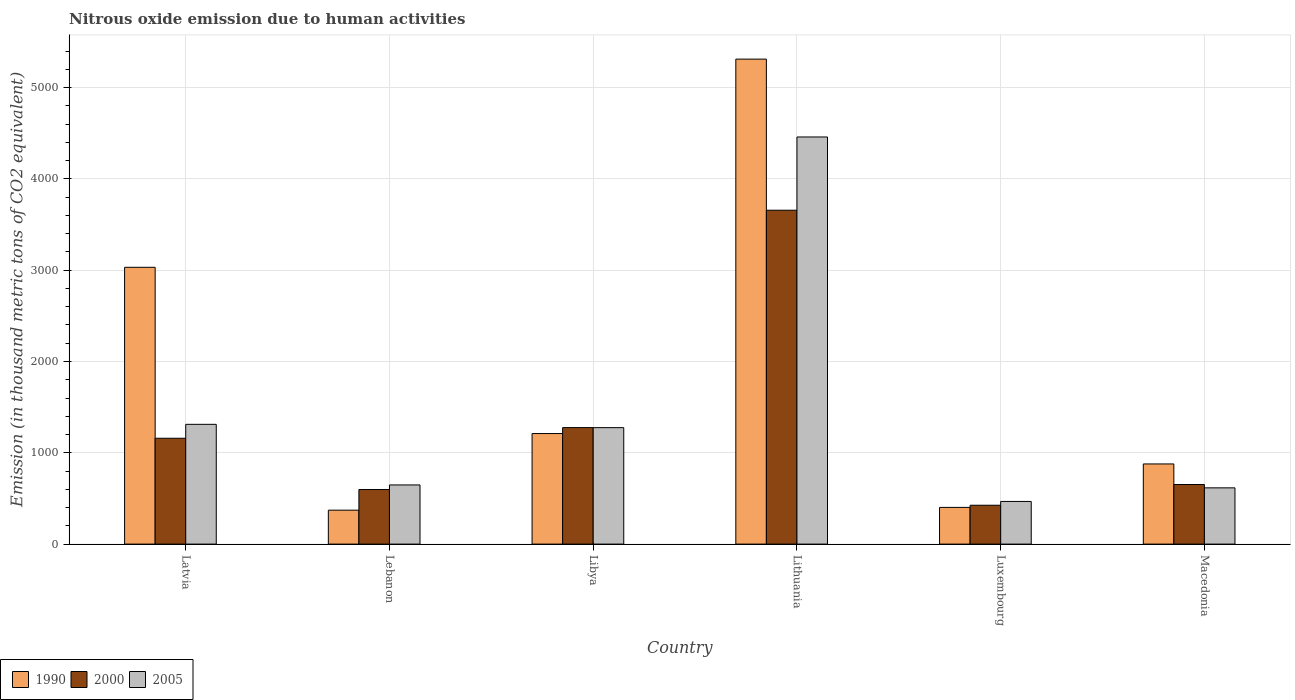How many bars are there on the 3rd tick from the left?
Your answer should be very brief. 3. How many bars are there on the 4th tick from the right?
Provide a short and direct response. 3. What is the label of the 1st group of bars from the left?
Your answer should be very brief. Latvia. What is the amount of nitrous oxide emitted in 2005 in Macedonia?
Your answer should be compact. 616.1. Across all countries, what is the maximum amount of nitrous oxide emitted in 2005?
Your response must be concise. 4459.4. Across all countries, what is the minimum amount of nitrous oxide emitted in 2005?
Make the answer very short. 467.2. In which country was the amount of nitrous oxide emitted in 2000 maximum?
Make the answer very short. Lithuania. In which country was the amount of nitrous oxide emitted in 2005 minimum?
Provide a short and direct response. Luxembourg. What is the total amount of nitrous oxide emitted in 2000 in the graph?
Offer a terse response. 7768.7. What is the difference between the amount of nitrous oxide emitted in 2005 in Lithuania and that in Macedonia?
Keep it short and to the point. 3843.3. What is the difference between the amount of nitrous oxide emitted in 2005 in Libya and the amount of nitrous oxide emitted in 2000 in Latvia?
Offer a terse response. 116.1. What is the average amount of nitrous oxide emitted in 1990 per country?
Offer a very short reply. 1867.7. What is the difference between the amount of nitrous oxide emitted of/in 2005 and amount of nitrous oxide emitted of/in 1990 in Lithuania?
Make the answer very short. -852.7. What is the ratio of the amount of nitrous oxide emitted in 1990 in Lithuania to that in Macedonia?
Your response must be concise. 6.05. Is the amount of nitrous oxide emitted in 1990 in Lithuania less than that in Luxembourg?
Provide a succinct answer. No. What is the difference between the highest and the second highest amount of nitrous oxide emitted in 1990?
Provide a succinct answer. 4101.3. What is the difference between the highest and the lowest amount of nitrous oxide emitted in 2000?
Provide a short and direct response. 3231.4. What does the 2nd bar from the right in Latvia represents?
Ensure brevity in your answer.  2000. How many bars are there?
Your answer should be compact. 18. What is the difference between two consecutive major ticks on the Y-axis?
Make the answer very short. 1000. Are the values on the major ticks of Y-axis written in scientific E-notation?
Your answer should be compact. No. Does the graph contain any zero values?
Provide a succinct answer. No. Does the graph contain grids?
Offer a terse response. Yes. Where does the legend appear in the graph?
Offer a very short reply. Bottom left. How many legend labels are there?
Make the answer very short. 3. How are the legend labels stacked?
Make the answer very short. Horizontal. What is the title of the graph?
Provide a short and direct response. Nitrous oxide emission due to human activities. What is the label or title of the X-axis?
Your answer should be compact. Country. What is the label or title of the Y-axis?
Your response must be concise. Emission (in thousand metric tons of CO2 equivalent). What is the Emission (in thousand metric tons of CO2 equivalent) of 1990 in Latvia?
Provide a succinct answer. 3031.8. What is the Emission (in thousand metric tons of CO2 equivalent) in 2000 in Latvia?
Offer a terse response. 1159.4. What is the Emission (in thousand metric tons of CO2 equivalent) in 2005 in Latvia?
Provide a short and direct response. 1311.8. What is the Emission (in thousand metric tons of CO2 equivalent) in 1990 in Lebanon?
Your answer should be compact. 371.6. What is the Emission (in thousand metric tons of CO2 equivalent) in 2000 in Lebanon?
Give a very brief answer. 597.8. What is the Emission (in thousand metric tons of CO2 equivalent) of 2005 in Lebanon?
Offer a terse response. 648. What is the Emission (in thousand metric tons of CO2 equivalent) of 1990 in Libya?
Offer a terse response. 1210.8. What is the Emission (in thousand metric tons of CO2 equivalent) of 2000 in Libya?
Ensure brevity in your answer.  1276.1. What is the Emission (in thousand metric tons of CO2 equivalent) in 2005 in Libya?
Offer a terse response. 1275.5. What is the Emission (in thousand metric tons of CO2 equivalent) in 1990 in Lithuania?
Your answer should be very brief. 5312.1. What is the Emission (in thousand metric tons of CO2 equivalent) of 2000 in Lithuania?
Your response must be concise. 3657. What is the Emission (in thousand metric tons of CO2 equivalent) of 2005 in Lithuania?
Make the answer very short. 4459.4. What is the Emission (in thousand metric tons of CO2 equivalent) of 1990 in Luxembourg?
Ensure brevity in your answer.  402. What is the Emission (in thousand metric tons of CO2 equivalent) in 2000 in Luxembourg?
Offer a terse response. 425.6. What is the Emission (in thousand metric tons of CO2 equivalent) in 2005 in Luxembourg?
Keep it short and to the point. 467.2. What is the Emission (in thousand metric tons of CO2 equivalent) in 1990 in Macedonia?
Offer a terse response. 877.9. What is the Emission (in thousand metric tons of CO2 equivalent) in 2000 in Macedonia?
Your response must be concise. 652.8. What is the Emission (in thousand metric tons of CO2 equivalent) of 2005 in Macedonia?
Keep it short and to the point. 616.1. Across all countries, what is the maximum Emission (in thousand metric tons of CO2 equivalent) of 1990?
Your response must be concise. 5312.1. Across all countries, what is the maximum Emission (in thousand metric tons of CO2 equivalent) in 2000?
Offer a terse response. 3657. Across all countries, what is the maximum Emission (in thousand metric tons of CO2 equivalent) in 2005?
Your answer should be compact. 4459.4. Across all countries, what is the minimum Emission (in thousand metric tons of CO2 equivalent) in 1990?
Make the answer very short. 371.6. Across all countries, what is the minimum Emission (in thousand metric tons of CO2 equivalent) of 2000?
Provide a short and direct response. 425.6. Across all countries, what is the minimum Emission (in thousand metric tons of CO2 equivalent) in 2005?
Provide a succinct answer. 467.2. What is the total Emission (in thousand metric tons of CO2 equivalent) of 1990 in the graph?
Ensure brevity in your answer.  1.12e+04. What is the total Emission (in thousand metric tons of CO2 equivalent) in 2000 in the graph?
Provide a succinct answer. 7768.7. What is the total Emission (in thousand metric tons of CO2 equivalent) of 2005 in the graph?
Provide a succinct answer. 8778. What is the difference between the Emission (in thousand metric tons of CO2 equivalent) in 1990 in Latvia and that in Lebanon?
Provide a succinct answer. 2660.2. What is the difference between the Emission (in thousand metric tons of CO2 equivalent) in 2000 in Latvia and that in Lebanon?
Offer a very short reply. 561.6. What is the difference between the Emission (in thousand metric tons of CO2 equivalent) of 2005 in Latvia and that in Lebanon?
Make the answer very short. 663.8. What is the difference between the Emission (in thousand metric tons of CO2 equivalent) of 1990 in Latvia and that in Libya?
Give a very brief answer. 1821. What is the difference between the Emission (in thousand metric tons of CO2 equivalent) in 2000 in Latvia and that in Libya?
Give a very brief answer. -116.7. What is the difference between the Emission (in thousand metric tons of CO2 equivalent) in 2005 in Latvia and that in Libya?
Offer a very short reply. 36.3. What is the difference between the Emission (in thousand metric tons of CO2 equivalent) of 1990 in Latvia and that in Lithuania?
Keep it short and to the point. -2280.3. What is the difference between the Emission (in thousand metric tons of CO2 equivalent) of 2000 in Latvia and that in Lithuania?
Offer a terse response. -2497.6. What is the difference between the Emission (in thousand metric tons of CO2 equivalent) of 2005 in Latvia and that in Lithuania?
Ensure brevity in your answer.  -3147.6. What is the difference between the Emission (in thousand metric tons of CO2 equivalent) of 1990 in Latvia and that in Luxembourg?
Your response must be concise. 2629.8. What is the difference between the Emission (in thousand metric tons of CO2 equivalent) in 2000 in Latvia and that in Luxembourg?
Your response must be concise. 733.8. What is the difference between the Emission (in thousand metric tons of CO2 equivalent) in 2005 in Latvia and that in Luxembourg?
Your response must be concise. 844.6. What is the difference between the Emission (in thousand metric tons of CO2 equivalent) of 1990 in Latvia and that in Macedonia?
Your answer should be very brief. 2153.9. What is the difference between the Emission (in thousand metric tons of CO2 equivalent) of 2000 in Latvia and that in Macedonia?
Offer a very short reply. 506.6. What is the difference between the Emission (in thousand metric tons of CO2 equivalent) of 2005 in Latvia and that in Macedonia?
Provide a short and direct response. 695.7. What is the difference between the Emission (in thousand metric tons of CO2 equivalent) of 1990 in Lebanon and that in Libya?
Provide a succinct answer. -839.2. What is the difference between the Emission (in thousand metric tons of CO2 equivalent) of 2000 in Lebanon and that in Libya?
Offer a terse response. -678.3. What is the difference between the Emission (in thousand metric tons of CO2 equivalent) of 2005 in Lebanon and that in Libya?
Provide a succinct answer. -627.5. What is the difference between the Emission (in thousand metric tons of CO2 equivalent) of 1990 in Lebanon and that in Lithuania?
Provide a succinct answer. -4940.5. What is the difference between the Emission (in thousand metric tons of CO2 equivalent) in 2000 in Lebanon and that in Lithuania?
Provide a short and direct response. -3059.2. What is the difference between the Emission (in thousand metric tons of CO2 equivalent) in 2005 in Lebanon and that in Lithuania?
Your response must be concise. -3811.4. What is the difference between the Emission (in thousand metric tons of CO2 equivalent) of 1990 in Lebanon and that in Luxembourg?
Give a very brief answer. -30.4. What is the difference between the Emission (in thousand metric tons of CO2 equivalent) in 2000 in Lebanon and that in Luxembourg?
Your response must be concise. 172.2. What is the difference between the Emission (in thousand metric tons of CO2 equivalent) of 2005 in Lebanon and that in Luxembourg?
Ensure brevity in your answer.  180.8. What is the difference between the Emission (in thousand metric tons of CO2 equivalent) in 1990 in Lebanon and that in Macedonia?
Your response must be concise. -506.3. What is the difference between the Emission (in thousand metric tons of CO2 equivalent) of 2000 in Lebanon and that in Macedonia?
Provide a short and direct response. -55. What is the difference between the Emission (in thousand metric tons of CO2 equivalent) of 2005 in Lebanon and that in Macedonia?
Your answer should be very brief. 31.9. What is the difference between the Emission (in thousand metric tons of CO2 equivalent) in 1990 in Libya and that in Lithuania?
Ensure brevity in your answer.  -4101.3. What is the difference between the Emission (in thousand metric tons of CO2 equivalent) of 2000 in Libya and that in Lithuania?
Your answer should be compact. -2380.9. What is the difference between the Emission (in thousand metric tons of CO2 equivalent) in 2005 in Libya and that in Lithuania?
Your answer should be compact. -3183.9. What is the difference between the Emission (in thousand metric tons of CO2 equivalent) of 1990 in Libya and that in Luxembourg?
Offer a very short reply. 808.8. What is the difference between the Emission (in thousand metric tons of CO2 equivalent) in 2000 in Libya and that in Luxembourg?
Your answer should be very brief. 850.5. What is the difference between the Emission (in thousand metric tons of CO2 equivalent) of 2005 in Libya and that in Luxembourg?
Offer a terse response. 808.3. What is the difference between the Emission (in thousand metric tons of CO2 equivalent) of 1990 in Libya and that in Macedonia?
Your response must be concise. 332.9. What is the difference between the Emission (in thousand metric tons of CO2 equivalent) of 2000 in Libya and that in Macedonia?
Give a very brief answer. 623.3. What is the difference between the Emission (in thousand metric tons of CO2 equivalent) in 2005 in Libya and that in Macedonia?
Your response must be concise. 659.4. What is the difference between the Emission (in thousand metric tons of CO2 equivalent) of 1990 in Lithuania and that in Luxembourg?
Your answer should be very brief. 4910.1. What is the difference between the Emission (in thousand metric tons of CO2 equivalent) of 2000 in Lithuania and that in Luxembourg?
Offer a very short reply. 3231.4. What is the difference between the Emission (in thousand metric tons of CO2 equivalent) in 2005 in Lithuania and that in Luxembourg?
Provide a short and direct response. 3992.2. What is the difference between the Emission (in thousand metric tons of CO2 equivalent) in 1990 in Lithuania and that in Macedonia?
Provide a short and direct response. 4434.2. What is the difference between the Emission (in thousand metric tons of CO2 equivalent) of 2000 in Lithuania and that in Macedonia?
Make the answer very short. 3004.2. What is the difference between the Emission (in thousand metric tons of CO2 equivalent) in 2005 in Lithuania and that in Macedonia?
Offer a very short reply. 3843.3. What is the difference between the Emission (in thousand metric tons of CO2 equivalent) in 1990 in Luxembourg and that in Macedonia?
Provide a short and direct response. -475.9. What is the difference between the Emission (in thousand metric tons of CO2 equivalent) in 2000 in Luxembourg and that in Macedonia?
Make the answer very short. -227.2. What is the difference between the Emission (in thousand metric tons of CO2 equivalent) of 2005 in Luxembourg and that in Macedonia?
Give a very brief answer. -148.9. What is the difference between the Emission (in thousand metric tons of CO2 equivalent) of 1990 in Latvia and the Emission (in thousand metric tons of CO2 equivalent) of 2000 in Lebanon?
Give a very brief answer. 2434. What is the difference between the Emission (in thousand metric tons of CO2 equivalent) in 1990 in Latvia and the Emission (in thousand metric tons of CO2 equivalent) in 2005 in Lebanon?
Offer a very short reply. 2383.8. What is the difference between the Emission (in thousand metric tons of CO2 equivalent) of 2000 in Latvia and the Emission (in thousand metric tons of CO2 equivalent) of 2005 in Lebanon?
Ensure brevity in your answer.  511.4. What is the difference between the Emission (in thousand metric tons of CO2 equivalent) of 1990 in Latvia and the Emission (in thousand metric tons of CO2 equivalent) of 2000 in Libya?
Offer a very short reply. 1755.7. What is the difference between the Emission (in thousand metric tons of CO2 equivalent) in 1990 in Latvia and the Emission (in thousand metric tons of CO2 equivalent) in 2005 in Libya?
Your response must be concise. 1756.3. What is the difference between the Emission (in thousand metric tons of CO2 equivalent) in 2000 in Latvia and the Emission (in thousand metric tons of CO2 equivalent) in 2005 in Libya?
Your answer should be very brief. -116.1. What is the difference between the Emission (in thousand metric tons of CO2 equivalent) in 1990 in Latvia and the Emission (in thousand metric tons of CO2 equivalent) in 2000 in Lithuania?
Provide a short and direct response. -625.2. What is the difference between the Emission (in thousand metric tons of CO2 equivalent) in 1990 in Latvia and the Emission (in thousand metric tons of CO2 equivalent) in 2005 in Lithuania?
Your answer should be compact. -1427.6. What is the difference between the Emission (in thousand metric tons of CO2 equivalent) in 2000 in Latvia and the Emission (in thousand metric tons of CO2 equivalent) in 2005 in Lithuania?
Give a very brief answer. -3300. What is the difference between the Emission (in thousand metric tons of CO2 equivalent) of 1990 in Latvia and the Emission (in thousand metric tons of CO2 equivalent) of 2000 in Luxembourg?
Your response must be concise. 2606.2. What is the difference between the Emission (in thousand metric tons of CO2 equivalent) of 1990 in Latvia and the Emission (in thousand metric tons of CO2 equivalent) of 2005 in Luxembourg?
Give a very brief answer. 2564.6. What is the difference between the Emission (in thousand metric tons of CO2 equivalent) of 2000 in Latvia and the Emission (in thousand metric tons of CO2 equivalent) of 2005 in Luxembourg?
Offer a terse response. 692.2. What is the difference between the Emission (in thousand metric tons of CO2 equivalent) in 1990 in Latvia and the Emission (in thousand metric tons of CO2 equivalent) in 2000 in Macedonia?
Your answer should be compact. 2379. What is the difference between the Emission (in thousand metric tons of CO2 equivalent) in 1990 in Latvia and the Emission (in thousand metric tons of CO2 equivalent) in 2005 in Macedonia?
Ensure brevity in your answer.  2415.7. What is the difference between the Emission (in thousand metric tons of CO2 equivalent) in 2000 in Latvia and the Emission (in thousand metric tons of CO2 equivalent) in 2005 in Macedonia?
Make the answer very short. 543.3. What is the difference between the Emission (in thousand metric tons of CO2 equivalent) in 1990 in Lebanon and the Emission (in thousand metric tons of CO2 equivalent) in 2000 in Libya?
Your response must be concise. -904.5. What is the difference between the Emission (in thousand metric tons of CO2 equivalent) in 1990 in Lebanon and the Emission (in thousand metric tons of CO2 equivalent) in 2005 in Libya?
Keep it short and to the point. -903.9. What is the difference between the Emission (in thousand metric tons of CO2 equivalent) in 2000 in Lebanon and the Emission (in thousand metric tons of CO2 equivalent) in 2005 in Libya?
Offer a terse response. -677.7. What is the difference between the Emission (in thousand metric tons of CO2 equivalent) of 1990 in Lebanon and the Emission (in thousand metric tons of CO2 equivalent) of 2000 in Lithuania?
Ensure brevity in your answer.  -3285.4. What is the difference between the Emission (in thousand metric tons of CO2 equivalent) in 1990 in Lebanon and the Emission (in thousand metric tons of CO2 equivalent) in 2005 in Lithuania?
Ensure brevity in your answer.  -4087.8. What is the difference between the Emission (in thousand metric tons of CO2 equivalent) in 2000 in Lebanon and the Emission (in thousand metric tons of CO2 equivalent) in 2005 in Lithuania?
Offer a terse response. -3861.6. What is the difference between the Emission (in thousand metric tons of CO2 equivalent) in 1990 in Lebanon and the Emission (in thousand metric tons of CO2 equivalent) in 2000 in Luxembourg?
Provide a succinct answer. -54. What is the difference between the Emission (in thousand metric tons of CO2 equivalent) of 1990 in Lebanon and the Emission (in thousand metric tons of CO2 equivalent) of 2005 in Luxembourg?
Your answer should be very brief. -95.6. What is the difference between the Emission (in thousand metric tons of CO2 equivalent) of 2000 in Lebanon and the Emission (in thousand metric tons of CO2 equivalent) of 2005 in Luxembourg?
Make the answer very short. 130.6. What is the difference between the Emission (in thousand metric tons of CO2 equivalent) of 1990 in Lebanon and the Emission (in thousand metric tons of CO2 equivalent) of 2000 in Macedonia?
Make the answer very short. -281.2. What is the difference between the Emission (in thousand metric tons of CO2 equivalent) of 1990 in Lebanon and the Emission (in thousand metric tons of CO2 equivalent) of 2005 in Macedonia?
Your answer should be very brief. -244.5. What is the difference between the Emission (in thousand metric tons of CO2 equivalent) in 2000 in Lebanon and the Emission (in thousand metric tons of CO2 equivalent) in 2005 in Macedonia?
Offer a very short reply. -18.3. What is the difference between the Emission (in thousand metric tons of CO2 equivalent) in 1990 in Libya and the Emission (in thousand metric tons of CO2 equivalent) in 2000 in Lithuania?
Offer a very short reply. -2446.2. What is the difference between the Emission (in thousand metric tons of CO2 equivalent) in 1990 in Libya and the Emission (in thousand metric tons of CO2 equivalent) in 2005 in Lithuania?
Make the answer very short. -3248.6. What is the difference between the Emission (in thousand metric tons of CO2 equivalent) in 2000 in Libya and the Emission (in thousand metric tons of CO2 equivalent) in 2005 in Lithuania?
Your answer should be compact. -3183.3. What is the difference between the Emission (in thousand metric tons of CO2 equivalent) in 1990 in Libya and the Emission (in thousand metric tons of CO2 equivalent) in 2000 in Luxembourg?
Your answer should be very brief. 785.2. What is the difference between the Emission (in thousand metric tons of CO2 equivalent) of 1990 in Libya and the Emission (in thousand metric tons of CO2 equivalent) of 2005 in Luxembourg?
Offer a terse response. 743.6. What is the difference between the Emission (in thousand metric tons of CO2 equivalent) of 2000 in Libya and the Emission (in thousand metric tons of CO2 equivalent) of 2005 in Luxembourg?
Offer a very short reply. 808.9. What is the difference between the Emission (in thousand metric tons of CO2 equivalent) of 1990 in Libya and the Emission (in thousand metric tons of CO2 equivalent) of 2000 in Macedonia?
Your response must be concise. 558. What is the difference between the Emission (in thousand metric tons of CO2 equivalent) of 1990 in Libya and the Emission (in thousand metric tons of CO2 equivalent) of 2005 in Macedonia?
Give a very brief answer. 594.7. What is the difference between the Emission (in thousand metric tons of CO2 equivalent) of 2000 in Libya and the Emission (in thousand metric tons of CO2 equivalent) of 2005 in Macedonia?
Your response must be concise. 660. What is the difference between the Emission (in thousand metric tons of CO2 equivalent) in 1990 in Lithuania and the Emission (in thousand metric tons of CO2 equivalent) in 2000 in Luxembourg?
Keep it short and to the point. 4886.5. What is the difference between the Emission (in thousand metric tons of CO2 equivalent) in 1990 in Lithuania and the Emission (in thousand metric tons of CO2 equivalent) in 2005 in Luxembourg?
Your answer should be compact. 4844.9. What is the difference between the Emission (in thousand metric tons of CO2 equivalent) in 2000 in Lithuania and the Emission (in thousand metric tons of CO2 equivalent) in 2005 in Luxembourg?
Ensure brevity in your answer.  3189.8. What is the difference between the Emission (in thousand metric tons of CO2 equivalent) of 1990 in Lithuania and the Emission (in thousand metric tons of CO2 equivalent) of 2000 in Macedonia?
Provide a succinct answer. 4659.3. What is the difference between the Emission (in thousand metric tons of CO2 equivalent) of 1990 in Lithuania and the Emission (in thousand metric tons of CO2 equivalent) of 2005 in Macedonia?
Provide a short and direct response. 4696. What is the difference between the Emission (in thousand metric tons of CO2 equivalent) in 2000 in Lithuania and the Emission (in thousand metric tons of CO2 equivalent) in 2005 in Macedonia?
Provide a succinct answer. 3040.9. What is the difference between the Emission (in thousand metric tons of CO2 equivalent) in 1990 in Luxembourg and the Emission (in thousand metric tons of CO2 equivalent) in 2000 in Macedonia?
Provide a short and direct response. -250.8. What is the difference between the Emission (in thousand metric tons of CO2 equivalent) in 1990 in Luxembourg and the Emission (in thousand metric tons of CO2 equivalent) in 2005 in Macedonia?
Ensure brevity in your answer.  -214.1. What is the difference between the Emission (in thousand metric tons of CO2 equivalent) in 2000 in Luxembourg and the Emission (in thousand metric tons of CO2 equivalent) in 2005 in Macedonia?
Keep it short and to the point. -190.5. What is the average Emission (in thousand metric tons of CO2 equivalent) in 1990 per country?
Your response must be concise. 1867.7. What is the average Emission (in thousand metric tons of CO2 equivalent) of 2000 per country?
Provide a short and direct response. 1294.78. What is the average Emission (in thousand metric tons of CO2 equivalent) in 2005 per country?
Give a very brief answer. 1463. What is the difference between the Emission (in thousand metric tons of CO2 equivalent) in 1990 and Emission (in thousand metric tons of CO2 equivalent) in 2000 in Latvia?
Offer a terse response. 1872.4. What is the difference between the Emission (in thousand metric tons of CO2 equivalent) in 1990 and Emission (in thousand metric tons of CO2 equivalent) in 2005 in Latvia?
Make the answer very short. 1720. What is the difference between the Emission (in thousand metric tons of CO2 equivalent) in 2000 and Emission (in thousand metric tons of CO2 equivalent) in 2005 in Latvia?
Your answer should be very brief. -152.4. What is the difference between the Emission (in thousand metric tons of CO2 equivalent) of 1990 and Emission (in thousand metric tons of CO2 equivalent) of 2000 in Lebanon?
Provide a short and direct response. -226.2. What is the difference between the Emission (in thousand metric tons of CO2 equivalent) in 1990 and Emission (in thousand metric tons of CO2 equivalent) in 2005 in Lebanon?
Ensure brevity in your answer.  -276.4. What is the difference between the Emission (in thousand metric tons of CO2 equivalent) of 2000 and Emission (in thousand metric tons of CO2 equivalent) of 2005 in Lebanon?
Provide a short and direct response. -50.2. What is the difference between the Emission (in thousand metric tons of CO2 equivalent) of 1990 and Emission (in thousand metric tons of CO2 equivalent) of 2000 in Libya?
Give a very brief answer. -65.3. What is the difference between the Emission (in thousand metric tons of CO2 equivalent) of 1990 and Emission (in thousand metric tons of CO2 equivalent) of 2005 in Libya?
Your answer should be compact. -64.7. What is the difference between the Emission (in thousand metric tons of CO2 equivalent) of 1990 and Emission (in thousand metric tons of CO2 equivalent) of 2000 in Lithuania?
Make the answer very short. 1655.1. What is the difference between the Emission (in thousand metric tons of CO2 equivalent) in 1990 and Emission (in thousand metric tons of CO2 equivalent) in 2005 in Lithuania?
Offer a very short reply. 852.7. What is the difference between the Emission (in thousand metric tons of CO2 equivalent) in 2000 and Emission (in thousand metric tons of CO2 equivalent) in 2005 in Lithuania?
Provide a succinct answer. -802.4. What is the difference between the Emission (in thousand metric tons of CO2 equivalent) in 1990 and Emission (in thousand metric tons of CO2 equivalent) in 2000 in Luxembourg?
Offer a terse response. -23.6. What is the difference between the Emission (in thousand metric tons of CO2 equivalent) of 1990 and Emission (in thousand metric tons of CO2 equivalent) of 2005 in Luxembourg?
Offer a very short reply. -65.2. What is the difference between the Emission (in thousand metric tons of CO2 equivalent) of 2000 and Emission (in thousand metric tons of CO2 equivalent) of 2005 in Luxembourg?
Give a very brief answer. -41.6. What is the difference between the Emission (in thousand metric tons of CO2 equivalent) in 1990 and Emission (in thousand metric tons of CO2 equivalent) in 2000 in Macedonia?
Your answer should be very brief. 225.1. What is the difference between the Emission (in thousand metric tons of CO2 equivalent) in 1990 and Emission (in thousand metric tons of CO2 equivalent) in 2005 in Macedonia?
Provide a short and direct response. 261.8. What is the difference between the Emission (in thousand metric tons of CO2 equivalent) in 2000 and Emission (in thousand metric tons of CO2 equivalent) in 2005 in Macedonia?
Keep it short and to the point. 36.7. What is the ratio of the Emission (in thousand metric tons of CO2 equivalent) in 1990 in Latvia to that in Lebanon?
Your answer should be compact. 8.16. What is the ratio of the Emission (in thousand metric tons of CO2 equivalent) of 2000 in Latvia to that in Lebanon?
Your answer should be very brief. 1.94. What is the ratio of the Emission (in thousand metric tons of CO2 equivalent) in 2005 in Latvia to that in Lebanon?
Offer a very short reply. 2.02. What is the ratio of the Emission (in thousand metric tons of CO2 equivalent) in 1990 in Latvia to that in Libya?
Offer a terse response. 2.5. What is the ratio of the Emission (in thousand metric tons of CO2 equivalent) in 2000 in Latvia to that in Libya?
Keep it short and to the point. 0.91. What is the ratio of the Emission (in thousand metric tons of CO2 equivalent) of 2005 in Latvia to that in Libya?
Your response must be concise. 1.03. What is the ratio of the Emission (in thousand metric tons of CO2 equivalent) in 1990 in Latvia to that in Lithuania?
Your answer should be very brief. 0.57. What is the ratio of the Emission (in thousand metric tons of CO2 equivalent) of 2000 in Latvia to that in Lithuania?
Ensure brevity in your answer.  0.32. What is the ratio of the Emission (in thousand metric tons of CO2 equivalent) in 2005 in Latvia to that in Lithuania?
Your response must be concise. 0.29. What is the ratio of the Emission (in thousand metric tons of CO2 equivalent) of 1990 in Latvia to that in Luxembourg?
Make the answer very short. 7.54. What is the ratio of the Emission (in thousand metric tons of CO2 equivalent) of 2000 in Latvia to that in Luxembourg?
Ensure brevity in your answer.  2.72. What is the ratio of the Emission (in thousand metric tons of CO2 equivalent) of 2005 in Latvia to that in Luxembourg?
Offer a very short reply. 2.81. What is the ratio of the Emission (in thousand metric tons of CO2 equivalent) in 1990 in Latvia to that in Macedonia?
Provide a succinct answer. 3.45. What is the ratio of the Emission (in thousand metric tons of CO2 equivalent) in 2000 in Latvia to that in Macedonia?
Ensure brevity in your answer.  1.78. What is the ratio of the Emission (in thousand metric tons of CO2 equivalent) of 2005 in Latvia to that in Macedonia?
Provide a succinct answer. 2.13. What is the ratio of the Emission (in thousand metric tons of CO2 equivalent) of 1990 in Lebanon to that in Libya?
Provide a succinct answer. 0.31. What is the ratio of the Emission (in thousand metric tons of CO2 equivalent) in 2000 in Lebanon to that in Libya?
Your answer should be very brief. 0.47. What is the ratio of the Emission (in thousand metric tons of CO2 equivalent) of 2005 in Lebanon to that in Libya?
Ensure brevity in your answer.  0.51. What is the ratio of the Emission (in thousand metric tons of CO2 equivalent) in 1990 in Lebanon to that in Lithuania?
Your response must be concise. 0.07. What is the ratio of the Emission (in thousand metric tons of CO2 equivalent) of 2000 in Lebanon to that in Lithuania?
Offer a very short reply. 0.16. What is the ratio of the Emission (in thousand metric tons of CO2 equivalent) of 2005 in Lebanon to that in Lithuania?
Give a very brief answer. 0.15. What is the ratio of the Emission (in thousand metric tons of CO2 equivalent) in 1990 in Lebanon to that in Luxembourg?
Provide a short and direct response. 0.92. What is the ratio of the Emission (in thousand metric tons of CO2 equivalent) of 2000 in Lebanon to that in Luxembourg?
Provide a short and direct response. 1.4. What is the ratio of the Emission (in thousand metric tons of CO2 equivalent) in 2005 in Lebanon to that in Luxembourg?
Make the answer very short. 1.39. What is the ratio of the Emission (in thousand metric tons of CO2 equivalent) of 1990 in Lebanon to that in Macedonia?
Provide a succinct answer. 0.42. What is the ratio of the Emission (in thousand metric tons of CO2 equivalent) of 2000 in Lebanon to that in Macedonia?
Offer a terse response. 0.92. What is the ratio of the Emission (in thousand metric tons of CO2 equivalent) of 2005 in Lebanon to that in Macedonia?
Offer a terse response. 1.05. What is the ratio of the Emission (in thousand metric tons of CO2 equivalent) of 1990 in Libya to that in Lithuania?
Offer a very short reply. 0.23. What is the ratio of the Emission (in thousand metric tons of CO2 equivalent) of 2000 in Libya to that in Lithuania?
Provide a succinct answer. 0.35. What is the ratio of the Emission (in thousand metric tons of CO2 equivalent) in 2005 in Libya to that in Lithuania?
Ensure brevity in your answer.  0.29. What is the ratio of the Emission (in thousand metric tons of CO2 equivalent) in 1990 in Libya to that in Luxembourg?
Ensure brevity in your answer.  3.01. What is the ratio of the Emission (in thousand metric tons of CO2 equivalent) in 2000 in Libya to that in Luxembourg?
Make the answer very short. 3. What is the ratio of the Emission (in thousand metric tons of CO2 equivalent) in 2005 in Libya to that in Luxembourg?
Offer a very short reply. 2.73. What is the ratio of the Emission (in thousand metric tons of CO2 equivalent) in 1990 in Libya to that in Macedonia?
Your response must be concise. 1.38. What is the ratio of the Emission (in thousand metric tons of CO2 equivalent) of 2000 in Libya to that in Macedonia?
Provide a succinct answer. 1.95. What is the ratio of the Emission (in thousand metric tons of CO2 equivalent) in 2005 in Libya to that in Macedonia?
Keep it short and to the point. 2.07. What is the ratio of the Emission (in thousand metric tons of CO2 equivalent) in 1990 in Lithuania to that in Luxembourg?
Provide a short and direct response. 13.21. What is the ratio of the Emission (in thousand metric tons of CO2 equivalent) in 2000 in Lithuania to that in Luxembourg?
Provide a short and direct response. 8.59. What is the ratio of the Emission (in thousand metric tons of CO2 equivalent) of 2005 in Lithuania to that in Luxembourg?
Provide a short and direct response. 9.54. What is the ratio of the Emission (in thousand metric tons of CO2 equivalent) in 1990 in Lithuania to that in Macedonia?
Ensure brevity in your answer.  6.05. What is the ratio of the Emission (in thousand metric tons of CO2 equivalent) of 2000 in Lithuania to that in Macedonia?
Offer a very short reply. 5.6. What is the ratio of the Emission (in thousand metric tons of CO2 equivalent) in 2005 in Lithuania to that in Macedonia?
Give a very brief answer. 7.24. What is the ratio of the Emission (in thousand metric tons of CO2 equivalent) of 1990 in Luxembourg to that in Macedonia?
Provide a short and direct response. 0.46. What is the ratio of the Emission (in thousand metric tons of CO2 equivalent) in 2000 in Luxembourg to that in Macedonia?
Offer a very short reply. 0.65. What is the ratio of the Emission (in thousand metric tons of CO2 equivalent) of 2005 in Luxembourg to that in Macedonia?
Give a very brief answer. 0.76. What is the difference between the highest and the second highest Emission (in thousand metric tons of CO2 equivalent) in 1990?
Offer a very short reply. 2280.3. What is the difference between the highest and the second highest Emission (in thousand metric tons of CO2 equivalent) in 2000?
Offer a very short reply. 2380.9. What is the difference between the highest and the second highest Emission (in thousand metric tons of CO2 equivalent) in 2005?
Your answer should be compact. 3147.6. What is the difference between the highest and the lowest Emission (in thousand metric tons of CO2 equivalent) in 1990?
Your answer should be compact. 4940.5. What is the difference between the highest and the lowest Emission (in thousand metric tons of CO2 equivalent) of 2000?
Keep it short and to the point. 3231.4. What is the difference between the highest and the lowest Emission (in thousand metric tons of CO2 equivalent) of 2005?
Provide a succinct answer. 3992.2. 